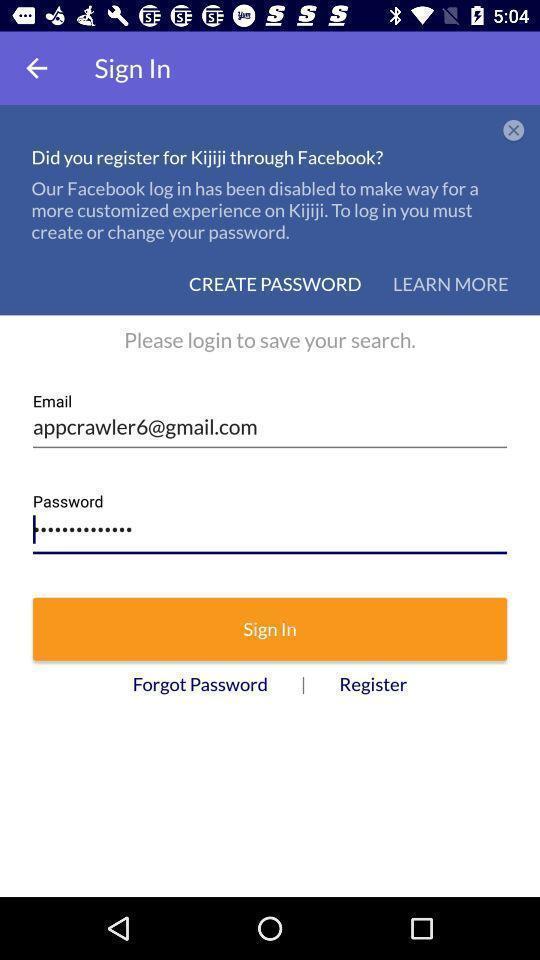Please provide a description for this image. Welcome to the sign in page. 